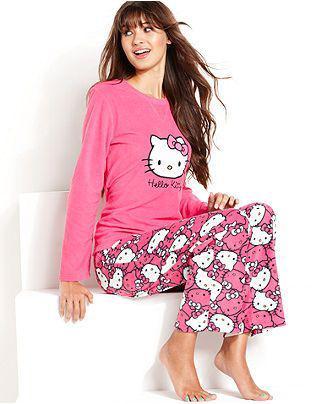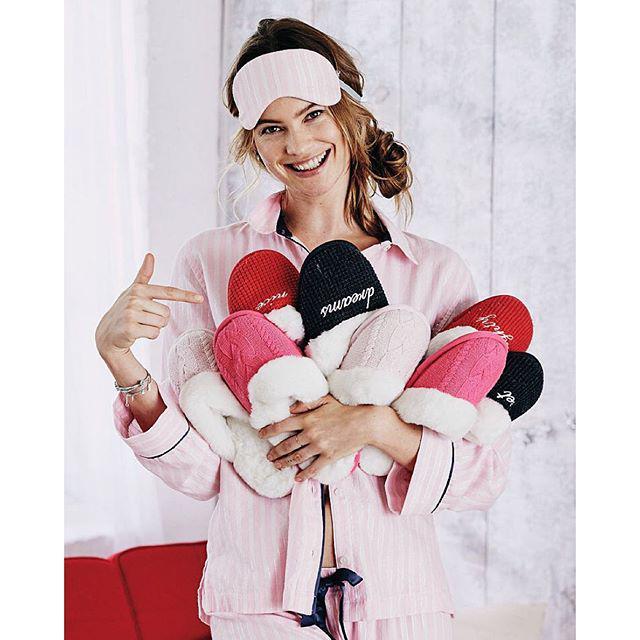The first image is the image on the left, the second image is the image on the right. Examine the images to the left and right. Is the description "A woman is holding an armload of slippers in at least one of the images." accurate? Answer yes or no. Yes. The first image is the image on the left, the second image is the image on the right. For the images displayed, is the sentence "At least one image in the pair shows a woman in pyjamas holding a lot of slippers." factually correct? Answer yes or no. Yes. 